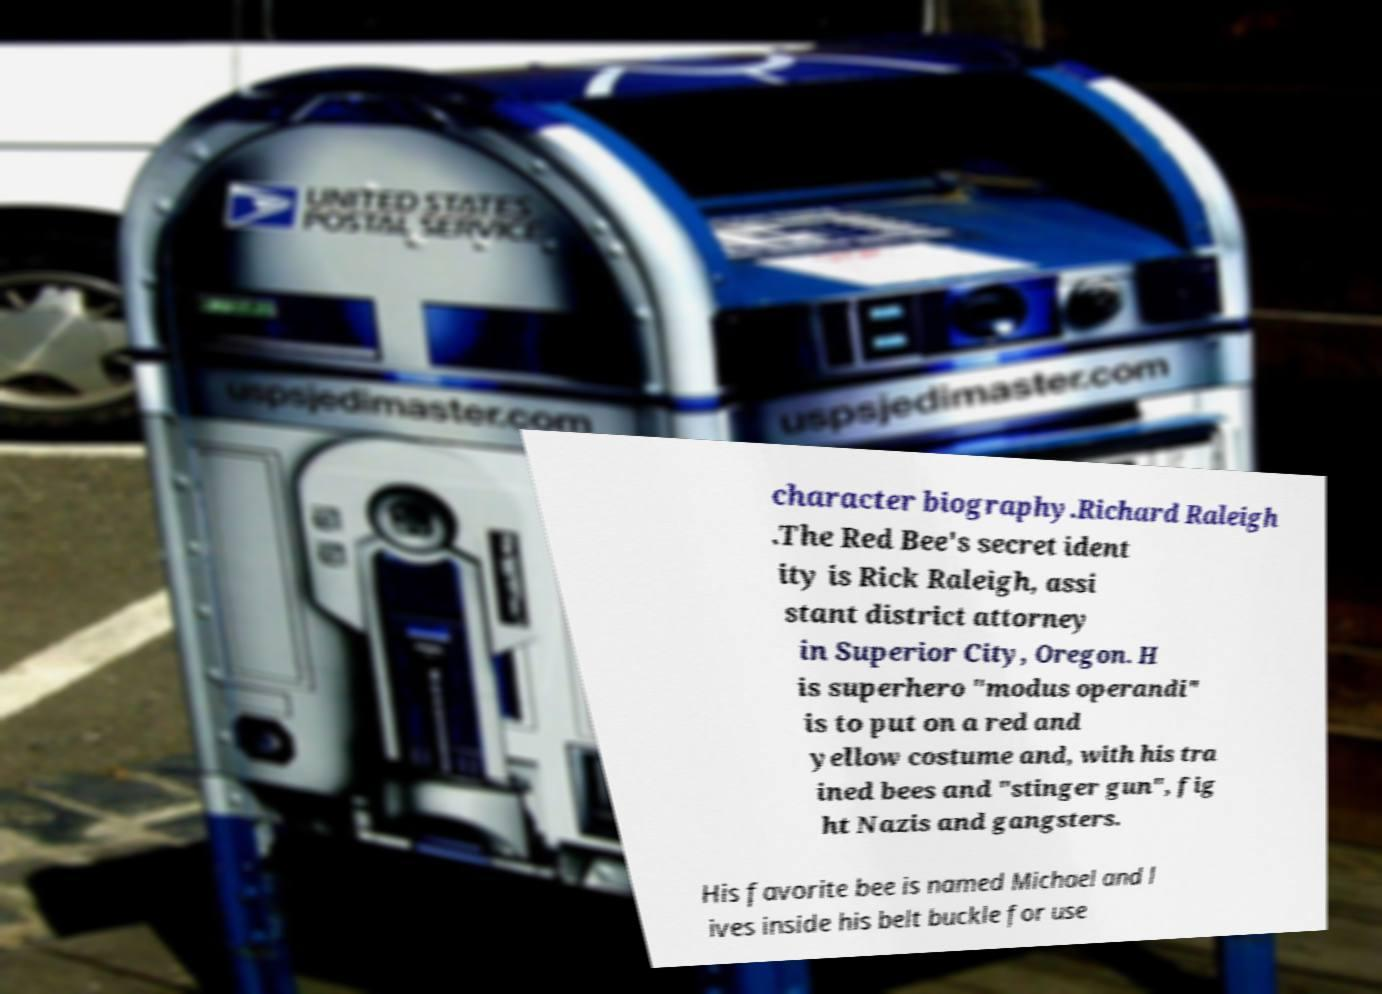Could you assist in decoding the text presented in this image and type it out clearly? character biography.Richard Raleigh .The Red Bee's secret ident ity is Rick Raleigh, assi stant district attorney in Superior City, Oregon. H is superhero "modus operandi" is to put on a red and yellow costume and, with his tra ined bees and "stinger gun", fig ht Nazis and gangsters. His favorite bee is named Michael and l ives inside his belt buckle for use 